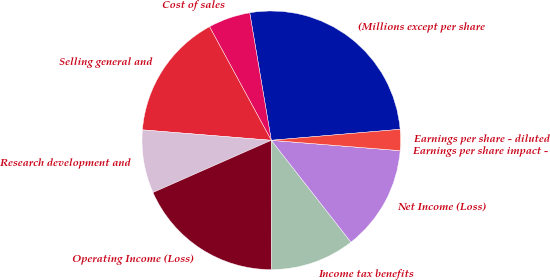<chart> <loc_0><loc_0><loc_500><loc_500><pie_chart><fcel>(Millions except per share<fcel>Cost of sales<fcel>Selling general and<fcel>Research development and<fcel>Operating Income (Loss)<fcel>Income tax benefits<fcel>Net Income (Loss)<fcel>Earnings per share impact -<fcel>Earnings per share - diluted<nl><fcel>26.31%<fcel>5.26%<fcel>15.79%<fcel>7.9%<fcel>18.42%<fcel>10.53%<fcel>13.16%<fcel>0.0%<fcel>2.63%<nl></chart> 